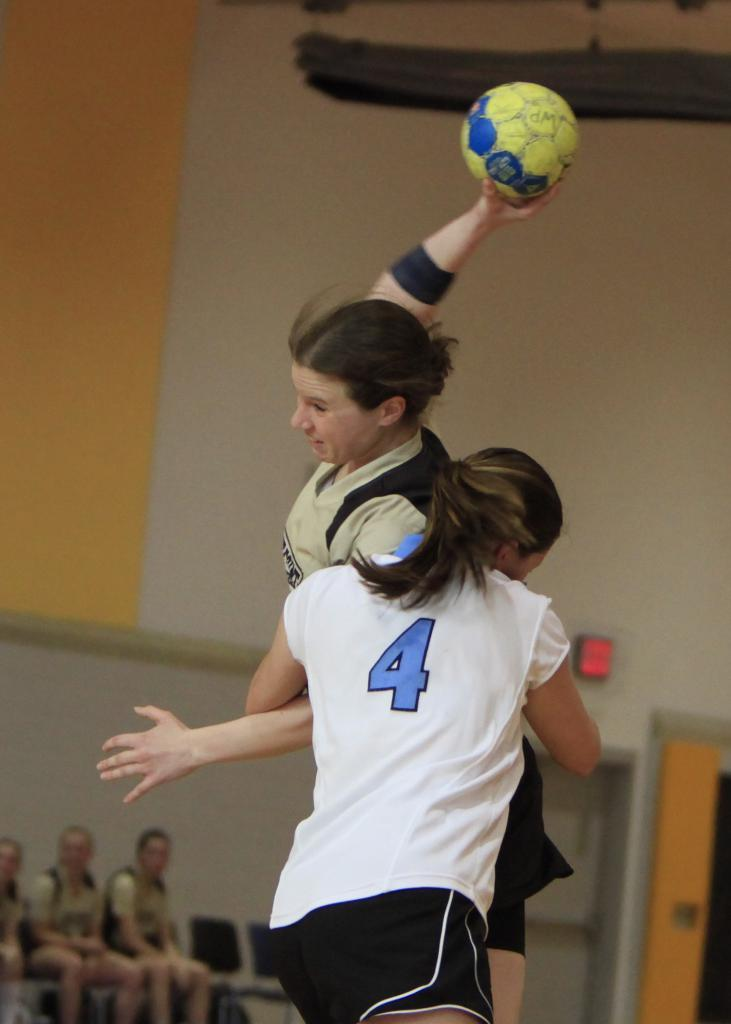Provide a one-sentence caption for the provided image. A game being played between female teams with number 4 attacking the opposing team to prevent scoring. 